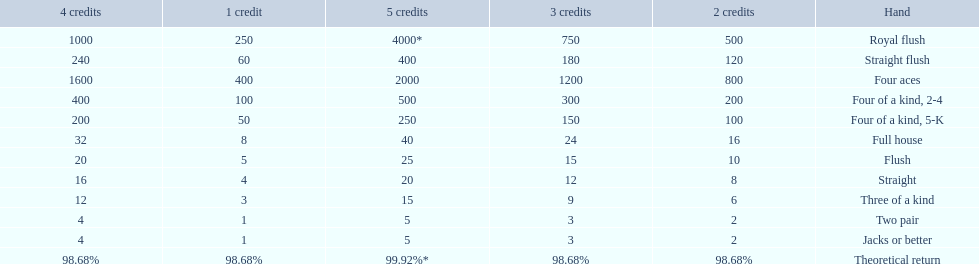After winning on four credits with a full house, what is your payout? 32. 